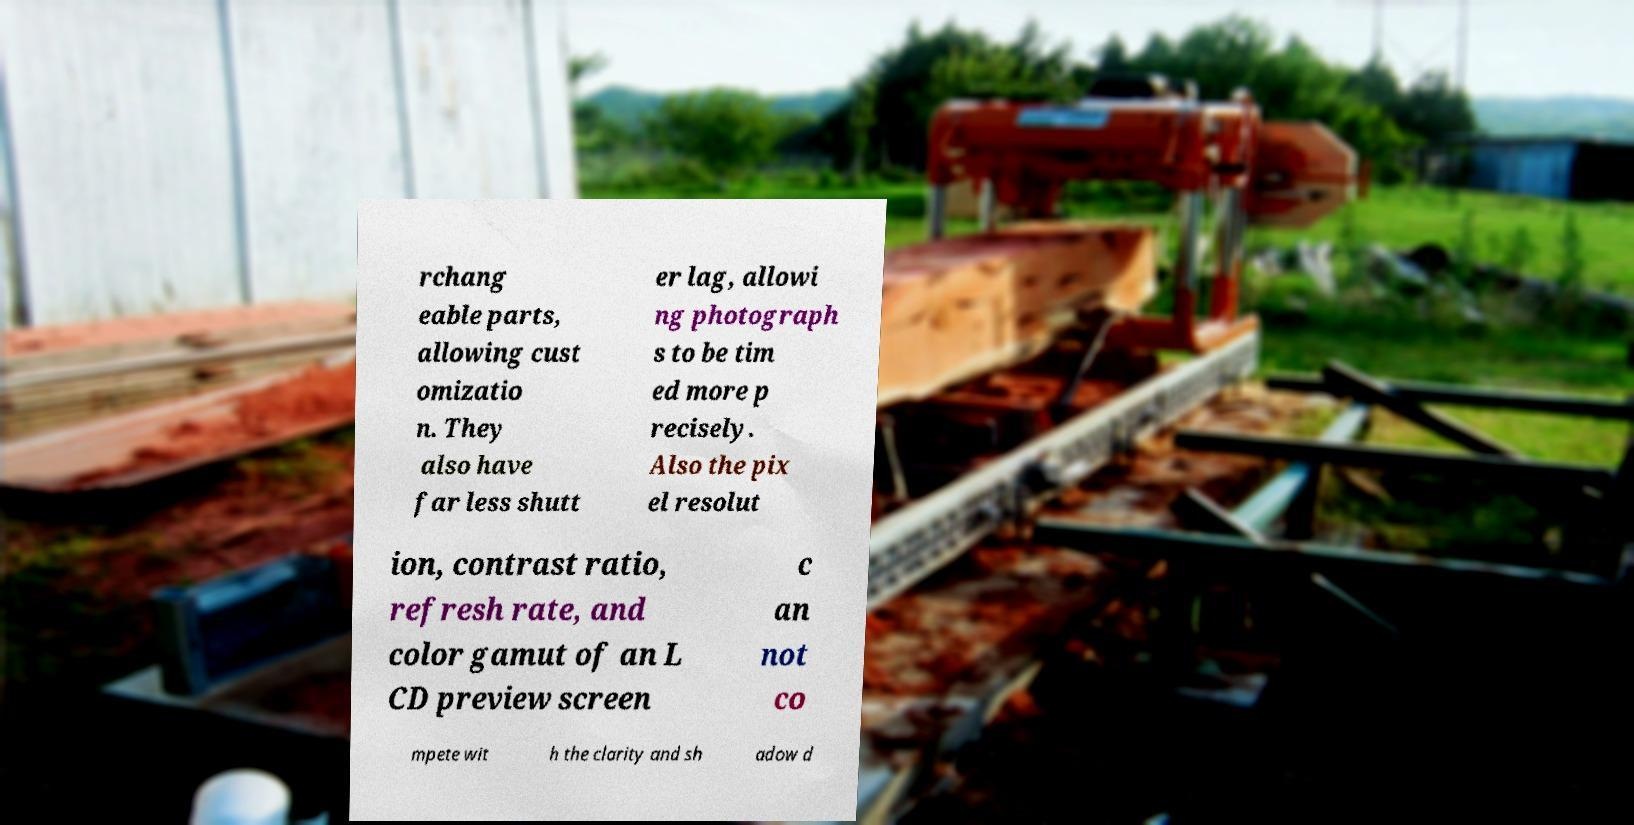Please read and relay the text visible in this image. What does it say? rchang eable parts, allowing cust omizatio n. They also have far less shutt er lag, allowi ng photograph s to be tim ed more p recisely. Also the pix el resolut ion, contrast ratio, refresh rate, and color gamut of an L CD preview screen c an not co mpete wit h the clarity and sh adow d 